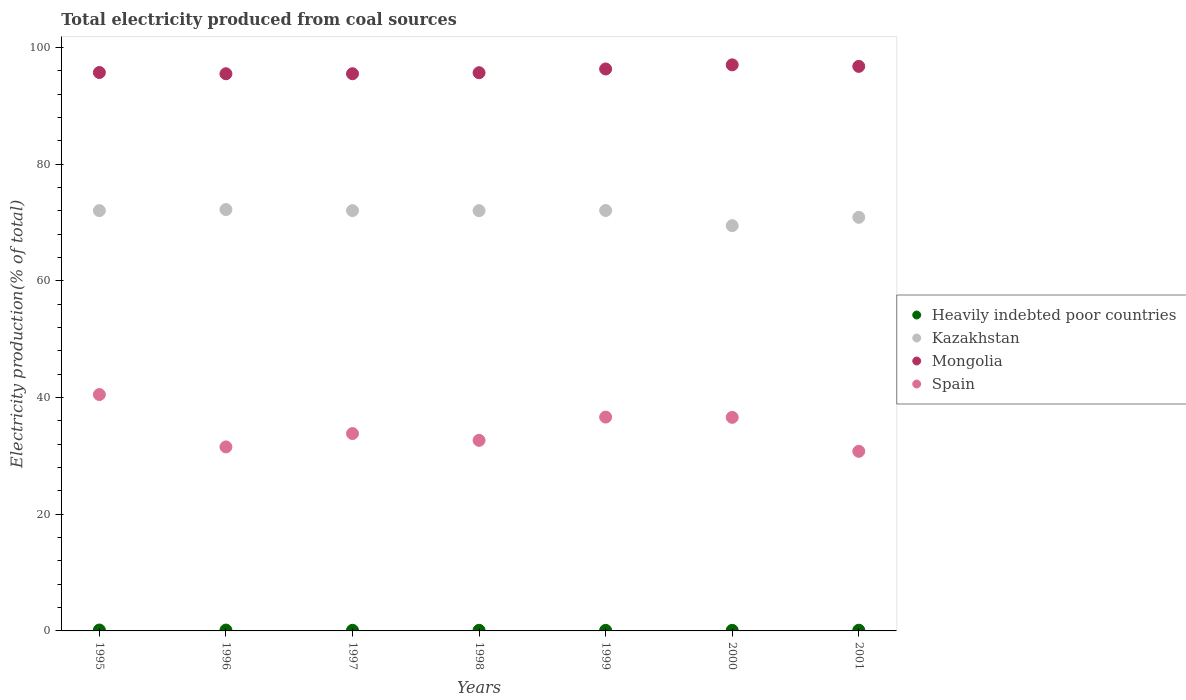How many different coloured dotlines are there?
Offer a terse response. 4. What is the total electricity produced in Spain in 1997?
Your response must be concise. 33.82. Across all years, what is the maximum total electricity produced in Kazakhstan?
Your answer should be very brief. 72.21. Across all years, what is the minimum total electricity produced in Spain?
Give a very brief answer. 30.78. In which year was the total electricity produced in Heavily indebted poor countries maximum?
Your response must be concise. 1995. What is the total total electricity produced in Spain in the graph?
Your answer should be very brief. 242.55. What is the difference between the total electricity produced in Heavily indebted poor countries in 1996 and that in 2001?
Your response must be concise. 0.02. What is the difference between the total electricity produced in Spain in 1998 and the total electricity produced in Heavily indebted poor countries in 1996?
Give a very brief answer. 32.52. What is the average total electricity produced in Kazakhstan per year?
Your answer should be very brief. 71.52. In the year 1999, what is the difference between the total electricity produced in Heavily indebted poor countries and total electricity produced in Spain?
Your response must be concise. -36.55. In how many years, is the total electricity produced in Heavily indebted poor countries greater than 92 %?
Offer a very short reply. 0. What is the ratio of the total electricity produced in Mongolia in 1995 to that in 2001?
Ensure brevity in your answer.  0.99. What is the difference between the highest and the second highest total electricity produced in Heavily indebted poor countries?
Ensure brevity in your answer.  0.01. What is the difference between the highest and the lowest total electricity produced in Mongolia?
Provide a short and direct response. 1.53. Is the sum of the total electricity produced in Kazakhstan in 1995 and 2001 greater than the maximum total electricity produced in Heavily indebted poor countries across all years?
Ensure brevity in your answer.  Yes. Is the total electricity produced in Heavily indebted poor countries strictly less than the total electricity produced in Spain over the years?
Provide a succinct answer. Yes. How many years are there in the graph?
Your response must be concise. 7. What is the difference between two consecutive major ticks on the Y-axis?
Ensure brevity in your answer.  20. Are the values on the major ticks of Y-axis written in scientific E-notation?
Your response must be concise. No. Does the graph contain grids?
Offer a very short reply. No. How many legend labels are there?
Offer a very short reply. 4. What is the title of the graph?
Offer a very short reply. Total electricity produced from coal sources. Does "Korea (Republic)" appear as one of the legend labels in the graph?
Your answer should be very brief. No. What is the label or title of the Y-axis?
Ensure brevity in your answer.  Electricity production(% of total). What is the Electricity production(% of total) in Heavily indebted poor countries in 1995?
Offer a terse response. 0.15. What is the Electricity production(% of total) of Kazakhstan in 1995?
Provide a short and direct response. 72.03. What is the Electricity production(% of total) in Mongolia in 1995?
Provide a short and direct response. 95.7. What is the Electricity production(% of total) in Spain in 1995?
Provide a short and direct response. 40.51. What is the Electricity production(% of total) in Heavily indebted poor countries in 1996?
Make the answer very short. 0.14. What is the Electricity production(% of total) of Kazakhstan in 1996?
Your answer should be very brief. 72.21. What is the Electricity production(% of total) of Mongolia in 1996?
Your response must be concise. 95.49. What is the Electricity production(% of total) of Spain in 1996?
Ensure brevity in your answer.  31.53. What is the Electricity production(% of total) of Heavily indebted poor countries in 1997?
Make the answer very short. 0.11. What is the Electricity production(% of total) of Kazakhstan in 1997?
Offer a very short reply. 72.03. What is the Electricity production(% of total) in Mongolia in 1997?
Ensure brevity in your answer.  95.49. What is the Electricity production(% of total) in Spain in 1997?
Give a very brief answer. 33.82. What is the Electricity production(% of total) in Heavily indebted poor countries in 1998?
Your response must be concise. 0.1. What is the Electricity production(% of total) in Kazakhstan in 1998?
Offer a terse response. 72.03. What is the Electricity production(% of total) in Mongolia in 1998?
Ensure brevity in your answer.  95.66. What is the Electricity production(% of total) of Spain in 1998?
Ensure brevity in your answer.  32.66. What is the Electricity production(% of total) in Heavily indebted poor countries in 1999?
Ensure brevity in your answer.  0.1. What is the Electricity production(% of total) in Kazakhstan in 1999?
Provide a succinct answer. 72.05. What is the Electricity production(% of total) of Mongolia in 1999?
Provide a short and direct response. 96.31. What is the Electricity production(% of total) in Spain in 1999?
Give a very brief answer. 36.65. What is the Electricity production(% of total) in Heavily indebted poor countries in 2000?
Provide a short and direct response. 0.1. What is the Electricity production(% of total) of Kazakhstan in 2000?
Offer a terse response. 69.45. What is the Electricity production(% of total) in Mongolia in 2000?
Your answer should be compact. 97.01. What is the Electricity production(% of total) in Spain in 2000?
Your answer should be very brief. 36.6. What is the Electricity production(% of total) of Heavily indebted poor countries in 2001?
Ensure brevity in your answer.  0.12. What is the Electricity production(% of total) of Kazakhstan in 2001?
Give a very brief answer. 70.88. What is the Electricity production(% of total) of Mongolia in 2001?
Make the answer very short. 96.75. What is the Electricity production(% of total) in Spain in 2001?
Give a very brief answer. 30.78. Across all years, what is the maximum Electricity production(% of total) of Heavily indebted poor countries?
Offer a very short reply. 0.15. Across all years, what is the maximum Electricity production(% of total) in Kazakhstan?
Provide a succinct answer. 72.21. Across all years, what is the maximum Electricity production(% of total) in Mongolia?
Provide a succinct answer. 97.01. Across all years, what is the maximum Electricity production(% of total) in Spain?
Give a very brief answer. 40.51. Across all years, what is the minimum Electricity production(% of total) in Heavily indebted poor countries?
Your answer should be compact. 0.1. Across all years, what is the minimum Electricity production(% of total) in Kazakhstan?
Your answer should be very brief. 69.45. Across all years, what is the minimum Electricity production(% of total) in Mongolia?
Your answer should be compact. 95.49. Across all years, what is the minimum Electricity production(% of total) in Spain?
Provide a short and direct response. 30.78. What is the total Electricity production(% of total) of Heavily indebted poor countries in the graph?
Give a very brief answer. 0.82. What is the total Electricity production(% of total) of Kazakhstan in the graph?
Give a very brief answer. 500.67. What is the total Electricity production(% of total) of Mongolia in the graph?
Keep it short and to the point. 672.41. What is the total Electricity production(% of total) in Spain in the graph?
Your answer should be compact. 242.55. What is the difference between the Electricity production(% of total) in Heavily indebted poor countries in 1995 and that in 1996?
Offer a terse response. 0.01. What is the difference between the Electricity production(% of total) in Kazakhstan in 1995 and that in 1996?
Provide a succinct answer. -0.18. What is the difference between the Electricity production(% of total) in Mongolia in 1995 and that in 1996?
Give a very brief answer. 0.21. What is the difference between the Electricity production(% of total) of Spain in 1995 and that in 1996?
Your answer should be compact. 8.97. What is the difference between the Electricity production(% of total) of Heavily indebted poor countries in 1995 and that in 1997?
Give a very brief answer. 0.05. What is the difference between the Electricity production(% of total) in Kazakhstan in 1995 and that in 1997?
Give a very brief answer. 0. What is the difference between the Electricity production(% of total) of Mongolia in 1995 and that in 1997?
Keep it short and to the point. 0.21. What is the difference between the Electricity production(% of total) in Spain in 1995 and that in 1997?
Your answer should be very brief. 6.68. What is the difference between the Electricity production(% of total) of Heavily indebted poor countries in 1995 and that in 1998?
Keep it short and to the point. 0.05. What is the difference between the Electricity production(% of total) of Kazakhstan in 1995 and that in 1998?
Your answer should be compact. 0. What is the difference between the Electricity production(% of total) in Mongolia in 1995 and that in 1998?
Give a very brief answer. 0.04. What is the difference between the Electricity production(% of total) of Spain in 1995 and that in 1998?
Make the answer very short. 7.85. What is the difference between the Electricity production(% of total) in Heavily indebted poor countries in 1995 and that in 1999?
Provide a succinct answer. 0.06. What is the difference between the Electricity production(% of total) in Kazakhstan in 1995 and that in 1999?
Your answer should be compact. -0.02. What is the difference between the Electricity production(% of total) of Mongolia in 1995 and that in 1999?
Keep it short and to the point. -0.61. What is the difference between the Electricity production(% of total) of Spain in 1995 and that in 1999?
Make the answer very short. 3.86. What is the difference between the Electricity production(% of total) of Heavily indebted poor countries in 1995 and that in 2000?
Your answer should be compact. 0.05. What is the difference between the Electricity production(% of total) in Kazakhstan in 1995 and that in 2000?
Provide a succinct answer. 2.58. What is the difference between the Electricity production(% of total) in Mongolia in 1995 and that in 2000?
Provide a succinct answer. -1.31. What is the difference between the Electricity production(% of total) in Spain in 1995 and that in 2000?
Offer a very short reply. 3.91. What is the difference between the Electricity production(% of total) in Heavily indebted poor countries in 1995 and that in 2001?
Keep it short and to the point. 0.03. What is the difference between the Electricity production(% of total) in Kazakhstan in 1995 and that in 2001?
Give a very brief answer. 1.15. What is the difference between the Electricity production(% of total) in Mongolia in 1995 and that in 2001?
Keep it short and to the point. -1.05. What is the difference between the Electricity production(% of total) in Spain in 1995 and that in 2001?
Your answer should be compact. 9.73. What is the difference between the Electricity production(% of total) in Heavily indebted poor countries in 1996 and that in 1997?
Keep it short and to the point. 0.04. What is the difference between the Electricity production(% of total) in Kazakhstan in 1996 and that in 1997?
Keep it short and to the point. 0.18. What is the difference between the Electricity production(% of total) of Mongolia in 1996 and that in 1997?
Ensure brevity in your answer.  -0.01. What is the difference between the Electricity production(% of total) in Spain in 1996 and that in 1997?
Your answer should be very brief. -2.29. What is the difference between the Electricity production(% of total) of Heavily indebted poor countries in 1996 and that in 1998?
Give a very brief answer. 0.04. What is the difference between the Electricity production(% of total) in Kazakhstan in 1996 and that in 1998?
Provide a succinct answer. 0.18. What is the difference between the Electricity production(% of total) of Mongolia in 1996 and that in 1998?
Offer a terse response. -0.18. What is the difference between the Electricity production(% of total) in Spain in 1996 and that in 1998?
Provide a succinct answer. -1.13. What is the difference between the Electricity production(% of total) in Heavily indebted poor countries in 1996 and that in 1999?
Offer a terse response. 0.05. What is the difference between the Electricity production(% of total) in Kazakhstan in 1996 and that in 1999?
Give a very brief answer. 0.16. What is the difference between the Electricity production(% of total) of Mongolia in 1996 and that in 1999?
Keep it short and to the point. -0.82. What is the difference between the Electricity production(% of total) of Spain in 1996 and that in 1999?
Provide a short and direct response. -5.11. What is the difference between the Electricity production(% of total) of Heavily indebted poor countries in 1996 and that in 2000?
Provide a succinct answer. 0.04. What is the difference between the Electricity production(% of total) in Kazakhstan in 1996 and that in 2000?
Make the answer very short. 2.76. What is the difference between the Electricity production(% of total) of Mongolia in 1996 and that in 2000?
Make the answer very short. -1.53. What is the difference between the Electricity production(% of total) of Spain in 1996 and that in 2000?
Provide a succinct answer. -5.07. What is the difference between the Electricity production(% of total) in Heavily indebted poor countries in 1996 and that in 2001?
Offer a very short reply. 0.02. What is the difference between the Electricity production(% of total) in Kazakhstan in 1996 and that in 2001?
Offer a very short reply. 1.33. What is the difference between the Electricity production(% of total) in Mongolia in 1996 and that in 2001?
Keep it short and to the point. -1.27. What is the difference between the Electricity production(% of total) in Spain in 1996 and that in 2001?
Your response must be concise. 0.76. What is the difference between the Electricity production(% of total) of Heavily indebted poor countries in 1997 and that in 1998?
Offer a terse response. 0. What is the difference between the Electricity production(% of total) in Kazakhstan in 1997 and that in 1998?
Your answer should be very brief. 0. What is the difference between the Electricity production(% of total) of Mongolia in 1997 and that in 1998?
Your answer should be compact. -0.17. What is the difference between the Electricity production(% of total) of Spain in 1997 and that in 1998?
Ensure brevity in your answer.  1.16. What is the difference between the Electricity production(% of total) in Heavily indebted poor countries in 1997 and that in 1999?
Give a very brief answer. 0.01. What is the difference between the Electricity production(% of total) in Kazakhstan in 1997 and that in 1999?
Offer a very short reply. -0.02. What is the difference between the Electricity production(% of total) of Mongolia in 1997 and that in 1999?
Make the answer very short. -0.81. What is the difference between the Electricity production(% of total) in Spain in 1997 and that in 1999?
Offer a very short reply. -2.83. What is the difference between the Electricity production(% of total) in Heavily indebted poor countries in 1997 and that in 2000?
Offer a very short reply. 0. What is the difference between the Electricity production(% of total) in Kazakhstan in 1997 and that in 2000?
Your response must be concise. 2.58. What is the difference between the Electricity production(% of total) of Mongolia in 1997 and that in 2000?
Your response must be concise. -1.52. What is the difference between the Electricity production(% of total) of Spain in 1997 and that in 2000?
Ensure brevity in your answer.  -2.78. What is the difference between the Electricity production(% of total) of Heavily indebted poor countries in 1997 and that in 2001?
Your answer should be very brief. -0.02. What is the difference between the Electricity production(% of total) of Kazakhstan in 1997 and that in 2001?
Your answer should be very brief. 1.15. What is the difference between the Electricity production(% of total) of Mongolia in 1997 and that in 2001?
Keep it short and to the point. -1.26. What is the difference between the Electricity production(% of total) of Spain in 1997 and that in 2001?
Give a very brief answer. 3.05. What is the difference between the Electricity production(% of total) of Heavily indebted poor countries in 1998 and that in 1999?
Ensure brevity in your answer.  0.01. What is the difference between the Electricity production(% of total) of Kazakhstan in 1998 and that in 1999?
Offer a terse response. -0.02. What is the difference between the Electricity production(% of total) in Mongolia in 1998 and that in 1999?
Give a very brief answer. -0.64. What is the difference between the Electricity production(% of total) in Spain in 1998 and that in 1999?
Offer a very short reply. -3.99. What is the difference between the Electricity production(% of total) in Heavily indebted poor countries in 1998 and that in 2000?
Provide a short and direct response. 0. What is the difference between the Electricity production(% of total) of Kazakhstan in 1998 and that in 2000?
Make the answer very short. 2.57. What is the difference between the Electricity production(% of total) of Mongolia in 1998 and that in 2000?
Offer a very short reply. -1.35. What is the difference between the Electricity production(% of total) in Spain in 1998 and that in 2000?
Provide a short and direct response. -3.94. What is the difference between the Electricity production(% of total) of Heavily indebted poor countries in 1998 and that in 2001?
Keep it short and to the point. -0.02. What is the difference between the Electricity production(% of total) in Kazakhstan in 1998 and that in 2001?
Make the answer very short. 1.14. What is the difference between the Electricity production(% of total) in Mongolia in 1998 and that in 2001?
Provide a short and direct response. -1.09. What is the difference between the Electricity production(% of total) in Spain in 1998 and that in 2001?
Offer a very short reply. 1.88. What is the difference between the Electricity production(% of total) in Heavily indebted poor countries in 1999 and that in 2000?
Provide a short and direct response. -0.01. What is the difference between the Electricity production(% of total) of Kazakhstan in 1999 and that in 2000?
Give a very brief answer. 2.6. What is the difference between the Electricity production(% of total) in Mongolia in 1999 and that in 2000?
Offer a terse response. -0.71. What is the difference between the Electricity production(% of total) of Spain in 1999 and that in 2000?
Your answer should be compact. 0.05. What is the difference between the Electricity production(% of total) in Heavily indebted poor countries in 1999 and that in 2001?
Make the answer very short. -0.03. What is the difference between the Electricity production(% of total) of Kazakhstan in 1999 and that in 2001?
Your response must be concise. 1.17. What is the difference between the Electricity production(% of total) of Mongolia in 1999 and that in 2001?
Offer a terse response. -0.45. What is the difference between the Electricity production(% of total) of Spain in 1999 and that in 2001?
Your answer should be very brief. 5.87. What is the difference between the Electricity production(% of total) in Heavily indebted poor countries in 2000 and that in 2001?
Your response must be concise. -0.02. What is the difference between the Electricity production(% of total) in Kazakhstan in 2000 and that in 2001?
Offer a very short reply. -1.43. What is the difference between the Electricity production(% of total) in Mongolia in 2000 and that in 2001?
Provide a short and direct response. 0.26. What is the difference between the Electricity production(% of total) in Spain in 2000 and that in 2001?
Ensure brevity in your answer.  5.82. What is the difference between the Electricity production(% of total) in Heavily indebted poor countries in 1995 and the Electricity production(% of total) in Kazakhstan in 1996?
Your answer should be compact. -72.06. What is the difference between the Electricity production(% of total) of Heavily indebted poor countries in 1995 and the Electricity production(% of total) of Mongolia in 1996?
Your answer should be very brief. -95.33. What is the difference between the Electricity production(% of total) of Heavily indebted poor countries in 1995 and the Electricity production(% of total) of Spain in 1996?
Ensure brevity in your answer.  -31.38. What is the difference between the Electricity production(% of total) in Kazakhstan in 1995 and the Electricity production(% of total) in Mongolia in 1996?
Ensure brevity in your answer.  -23.46. What is the difference between the Electricity production(% of total) of Kazakhstan in 1995 and the Electricity production(% of total) of Spain in 1996?
Make the answer very short. 40.5. What is the difference between the Electricity production(% of total) of Mongolia in 1995 and the Electricity production(% of total) of Spain in 1996?
Offer a terse response. 64.17. What is the difference between the Electricity production(% of total) of Heavily indebted poor countries in 1995 and the Electricity production(% of total) of Kazakhstan in 1997?
Make the answer very short. -71.88. What is the difference between the Electricity production(% of total) in Heavily indebted poor countries in 1995 and the Electricity production(% of total) in Mongolia in 1997?
Offer a terse response. -95.34. What is the difference between the Electricity production(% of total) in Heavily indebted poor countries in 1995 and the Electricity production(% of total) in Spain in 1997?
Provide a short and direct response. -33.67. What is the difference between the Electricity production(% of total) of Kazakhstan in 1995 and the Electricity production(% of total) of Mongolia in 1997?
Offer a very short reply. -23.46. What is the difference between the Electricity production(% of total) in Kazakhstan in 1995 and the Electricity production(% of total) in Spain in 1997?
Provide a succinct answer. 38.21. What is the difference between the Electricity production(% of total) of Mongolia in 1995 and the Electricity production(% of total) of Spain in 1997?
Provide a succinct answer. 61.88. What is the difference between the Electricity production(% of total) in Heavily indebted poor countries in 1995 and the Electricity production(% of total) in Kazakhstan in 1998?
Your answer should be compact. -71.87. What is the difference between the Electricity production(% of total) in Heavily indebted poor countries in 1995 and the Electricity production(% of total) in Mongolia in 1998?
Your answer should be very brief. -95.51. What is the difference between the Electricity production(% of total) of Heavily indebted poor countries in 1995 and the Electricity production(% of total) of Spain in 1998?
Your answer should be very brief. -32.51. What is the difference between the Electricity production(% of total) of Kazakhstan in 1995 and the Electricity production(% of total) of Mongolia in 1998?
Make the answer very short. -23.63. What is the difference between the Electricity production(% of total) of Kazakhstan in 1995 and the Electricity production(% of total) of Spain in 1998?
Give a very brief answer. 39.37. What is the difference between the Electricity production(% of total) in Mongolia in 1995 and the Electricity production(% of total) in Spain in 1998?
Make the answer very short. 63.04. What is the difference between the Electricity production(% of total) of Heavily indebted poor countries in 1995 and the Electricity production(% of total) of Kazakhstan in 1999?
Ensure brevity in your answer.  -71.89. What is the difference between the Electricity production(% of total) in Heavily indebted poor countries in 1995 and the Electricity production(% of total) in Mongolia in 1999?
Ensure brevity in your answer.  -96.15. What is the difference between the Electricity production(% of total) in Heavily indebted poor countries in 1995 and the Electricity production(% of total) in Spain in 1999?
Your answer should be very brief. -36.5. What is the difference between the Electricity production(% of total) in Kazakhstan in 1995 and the Electricity production(% of total) in Mongolia in 1999?
Offer a terse response. -24.28. What is the difference between the Electricity production(% of total) of Kazakhstan in 1995 and the Electricity production(% of total) of Spain in 1999?
Provide a short and direct response. 35.38. What is the difference between the Electricity production(% of total) in Mongolia in 1995 and the Electricity production(% of total) in Spain in 1999?
Keep it short and to the point. 59.05. What is the difference between the Electricity production(% of total) in Heavily indebted poor countries in 1995 and the Electricity production(% of total) in Kazakhstan in 2000?
Make the answer very short. -69.3. What is the difference between the Electricity production(% of total) in Heavily indebted poor countries in 1995 and the Electricity production(% of total) in Mongolia in 2000?
Ensure brevity in your answer.  -96.86. What is the difference between the Electricity production(% of total) in Heavily indebted poor countries in 1995 and the Electricity production(% of total) in Spain in 2000?
Ensure brevity in your answer.  -36.45. What is the difference between the Electricity production(% of total) of Kazakhstan in 1995 and the Electricity production(% of total) of Mongolia in 2000?
Give a very brief answer. -24.98. What is the difference between the Electricity production(% of total) of Kazakhstan in 1995 and the Electricity production(% of total) of Spain in 2000?
Your response must be concise. 35.43. What is the difference between the Electricity production(% of total) in Mongolia in 1995 and the Electricity production(% of total) in Spain in 2000?
Keep it short and to the point. 59.1. What is the difference between the Electricity production(% of total) of Heavily indebted poor countries in 1995 and the Electricity production(% of total) of Kazakhstan in 2001?
Keep it short and to the point. -70.73. What is the difference between the Electricity production(% of total) in Heavily indebted poor countries in 1995 and the Electricity production(% of total) in Mongolia in 2001?
Give a very brief answer. -96.6. What is the difference between the Electricity production(% of total) in Heavily indebted poor countries in 1995 and the Electricity production(% of total) in Spain in 2001?
Keep it short and to the point. -30.63. What is the difference between the Electricity production(% of total) in Kazakhstan in 1995 and the Electricity production(% of total) in Mongolia in 2001?
Provide a short and direct response. -24.72. What is the difference between the Electricity production(% of total) in Kazakhstan in 1995 and the Electricity production(% of total) in Spain in 2001?
Your answer should be compact. 41.25. What is the difference between the Electricity production(% of total) in Mongolia in 1995 and the Electricity production(% of total) in Spain in 2001?
Make the answer very short. 64.92. What is the difference between the Electricity production(% of total) in Heavily indebted poor countries in 1996 and the Electricity production(% of total) in Kazakhstan in 1997?
Your response must be concise. -71.89. What is the difference between the Electricity production(% of total) of Heavily indebted poor countries in 1996 and the Electricity production(% of total) of Mongolia in 1997?
Offer a terse response. -95.35. What is the difference between the Electricity production(% of total) of Heavily indebted poor countries in 1996 and the Electricity production(% of total) of Spain in 1997?
Offer a terse response. -33.68. What is the difference between the Electricity production(% of total) in Kazakhstan in 1996 and the Electricity production(% of total) in Mongolia in 1997?
Your answer should be very brief. -23.28. What is the difference between the Electricity production(% of total) of Kazakhstan in 1996 and the Electricity production(% of total) of Spain in 1997?
Your response must be concise. 38.39. What is the difference between the Electricity production(% of total) in Mongolia in 1996 and the Electricity production(% of total) in Spain in 1997?
Make the answer very short. 61.66. What is the difference between the Electricity production(% of total) in Heavily indebted poor countries in 1996 and the Electricity production(% of total) in Kazakhstan in 1998?
Keep it short and to the point. -71.88. What is the difference between the Electricity production(% of total) of Heavily indebted poor countries in 1996 and the Electricity production(% of total) of Mongolia in 1998?
Offer a terse response. -95.52. What is the difference between the Electricity production(% of total) in Heavily indebted poor countries in 1996 and the Electricity production(% of total) in Spain in 1998?
Your answer should be very brief. -32.52. What is the difference between the Electricity production(% of total) of Kazakhstan in 1996 and the Electricity production(% of total) of Mongolia in 1998?
Make the answer very short. -23.45. What is the difference between the Electricity production(% of total) in Kazakhstan in 1996 and the Electricity production(% of total) in Spain in 1998?
Offer a very short reply. 39.55. What is the difference between the Electricity production(% of total) of Mongolia in 1996 and the Electricity production(% of total) of Spain in 1998?
Keep it short and to the point. 62.82. What is the difference between the Electricity production(% of total) of Heavily indebted poor countries in 1996 and the Electricity production(% of total) of Kazakhstan in 1999?
Your response must be concise. -71.9. What is the difference between the Electricity production(% of total) of Heavily indebted poor countries in 1996 and the Electricity production(% of total) of Mongolia in 1999?
Offer a terse response. -96.16. What is the difference between the Electricity production(% of total) of Heavily indebted poor countries in 1996 and the Electricity production(% of total) of Spain in 1999?
Provide a succinct answer. -36.51. What is the difference between the Electricity production(% of total) in Kazakhstan in 1996 and the Electricity production(% of total) in Mongolia in 1999?
Your answer should be compact. -24.1. What is the difference between the Electricity production(% of total) in Kazakhstan in 1996 and the Electricity production(% of total) in Spain in 1999?
Offer a terse response. 35.56. What is the difference between the Electricity production(% of total) in Mongolia in 1996 and the Electricity production(% of total) in Spain in 1999?
Your response must be concise. 58.84. What is the difference between the Electricity production(% of total) in Heavily indebted poor countries in 1996 and the Electricity production(% of total) in Kazakhstan in 2000?
Ensure brevity in your answer.  -69.31. What is the difference between the Electricity production(% of total) in Heavily indebted poor countries in 1996 and the Electricity production(% of total) in Mongolia in 2000?
Provide a succinct answer. -96.87. What is the difference between the Electricity production(% of total) in Heavily indebted poor countries in 1996 and the Electricity production(% of total) in Spain in 2000?
Your response must be concise. -36.46. What is the difference between the Electricity production(% of total) in Kazakhstan in 1996 and the Electricity production(% of total) in Mongolia in 2000?
Provide a short and direct response. -24.8. What is the difference between the Electricity production(% of total) of Kazakhstan in 1996 and the Electricity production(% of total) of Spain in 2000?
Ensure brevity in your answer.  35.61. What is the difference between the Electricity production(% of total) in Mongolia in 1996 and the Electricity production(% of total) in Spain in 2000?
Your answer should be very brief. 58.89. What is the difference between the Electricity production(% of total) in Heavily indebted poor countries in 1996 and the Electricity production(% of total) in Kazakhstan in 2001?
Provide a succinct answer. -70.74. What is the difference between the Electricity production(% of total) in Heavily indebted poor countries in 1996 and the Electricity production(% of total) in Mongolia in 2001?
Your answer should be compact. -96.61. What is the difference between the Electricity production(% of total) of Heavily indebted poor countries in 1996 and the Electricity production(% of total) of Spain in 2001?
Give a very brief answer. -30.64. What is the difference between the Electricity production(% of total) in Kazakhstan in 1996 and the Electricity production(% of total) in Mongolia in 2001?
Provide a succinct answer. -24.54. What is the difference between the Electricity production(% of total) of Kazakhstan in 1996 and the Electricity production(% of total) of Spain in 2001?
Offer a very short reply. 41.43. What is the difference between the Electricity production(% of total) of Mongolia in 1996 and the Electricity production(% of total) of Spain in 2001?
Give a very brief answer. 64.71. What is the difference between the Electricity production(% of total) of Heavily indebted poor countries in 1997 and the Electricity production(% of total) of Kazakhstan in 1998?
Your answer should be very brief. -71.92. What is the difference between the Electricity production(% of total) of Heavily indebted poor countries in 1997 and the Electricity production(% of total) of Mongolia in 1998?
Keep it short and to the point. -95.56. What is the difference between the Electricity production(% of total) in Heavily indebted poor countries in 1997 and the Electricity production(% of total) in Spain in 1998?
Ensure brevity in your answer.  -32.56. What is the difference between the Electricity production(% of total) of Kazakhstan in 1997 and the Electricity production(% of total) of Mongolia in 1998?
Make the answer very short. -23.63. What is the difference between the Electricity production(% of total) of Kazakhstan in 1997 and the Electricity production(% of total) of Spain in 1998?
Make the answer very short. 39.37. What is the difference between the Electricity production(% of total) in Mongolia in 1997 and the Electricity production(% of total) in Spain in 1998?
Provide a short and direct response. 62.83. What is the difference between the Electricity production(% of total) of Heavily indebted poor countries in 1997 and the Electricity production(% of total) of Kazakhstan in 1999?
Provide a succinct answer. -71.94. What is the difference between the Electricity production(% of total) in Heavily indebted poor countries in 1997 and the Electricity production(% of total) in Mongolia in 1999?
Provide a short and direct response. -96.2. What is the difference between the Electricity production(% of total) in Heavily indebted poor countries in 1997 and the Electricity production(% of total) in Spain in 1999?
Keep it short and to the point. -36.54. What is the difference between the Electricity production(% of total) of Kazakhstan in 1997 and the Electricity production(% of total) of Mongolia in 1999?
Offer a very short reply. -24.28. What is the difference between the Electricity production(% of total) in Kazakhstan in 1997 and the Electricity production(% of total) in Spain in 1999?
Your answer should be compact. 35.38. What is the difference between the Electricity production(% of total) of Mongolia in 1997 and the Electricity production(% of total) of Spain in 1999?
Give a very brief answer. 58.84. What is the difference between the Electricity production(% of total) of Heavily indebted poor countries in 1997 and the Electricity production(% of total) of Kazakhstan in 2000?
Provide a succinct answer. -69.35. What is the difference between the Electricity production(% of total) in Heavily indebted poor countries in 1997 and the Electricity production(% of total) in Mongolia in 2000?
Provide a succinct answer. -96.91. What is the difference between the Electricity production(% of total) of Heavily indebted poor countries in 1997 and the Electricity production(% of total) of Spain in 2000?
Your answer should be very brief. -36.49. What is the difference between the Electricity production(% of total) of Kazakhstan in 1997 and the Electricity production(% of total) of Mongolia in 2000?
Offer a terse response. -24.98. What is the difference between the Electricity production(% of total) of Kazakhstan in 1997 and the Electricity production(% of total) of Spain in 2000?
Provide a short and direct response. 35.43. What is the difference between the Electricity production(% of total) in Mongolia in 1997 and the Electricity production(% of total) in Spain in 2000?
Provide a short and direct response. 58.89. What is the difference between the Electricity production(% of total) of Heavily indebted poor countries in 1997 and the Electricity production(% of total) of Kazakhstan in 2001?
Your response must be concise. -70.78. What is the difference between the Electricity production(% of total) of Heavily indebted poor countries in 1997 and the Electricity production(% of total) of Mongolia in 2001?
Keep it short and to the point. -96.65. What is the difference between the Electricity production(% of total) of Heavily indebted poor countries in 1997 and the Electricity production(% of total) of Spain in 2001?
Offer a very short reply. -30.67. What is the difference between the Electricity production(% of total) in Kazakhstan in 1997 and the Electricity production(% of total) in Mongolia in 2001?
Give a very brief answer. -24.72. What is the difference between the Electricity production(% of total) of Kazakhstan in 1997 and the Electricity production(% of total) of Spain in 2001?
Ensure brevity in your answer.  41.25. What is the difference between the Electricity production(% of total) in Mongolia in 1997 and the Electricity production(% of total) in Spain in 2001?
Your response must be concise. 64.71. What is the difference between the Electricity production(% of total) in Heavily indebted poor countries in 1998 and the Electricity production(% of total) in Kazakhstan in 1999?
Keep it short and to the point. -71.94. What is the difference between the Electricity production(% of total) in Heavily indebted poor countries in 1998 and the Electricity production(% of total) in Mongolia in 1999?
Provide a succinct answer. -96.2. What is the difference between the Electricity production(% of total) in Heavily indebted poor countries in 1998 and the Electricity production(% of total) in Spain in 1999?
Provide a succinct answer. -36.54. What is the difference between the Electricity production(% of total) in Kazakhstan in 1998 and the Electricity production(% of total) in Mongolia in 1999?
Provide a succinct answer. -24.28. What is the difference between the Electricity production(% of total) in Kazakhstan in 1998 and the Electricity production(% of total) in Spain in 1999?
Offer a very short reply. 35.38. What is the difference between the Electricity production(% of total) of Mongolia in 1998 and the Electricity production(% of total) of Spain in 1999?
Your answer should be very brief. 59.02. What is the difference between the Electricity production(% of total) of Heavily indebted poor countries in 1998 and the Electricity production(% of total) of Kazakhstan in 2000?
Make the answer very short. -69.35. What is the difference between the Electricity production(% of total) of Heavily indebted poor countries in 1998 and the Electricity production(% of total) of Mongolia in 2000?
Your response must be concise. -96.91. What is the difference between the Electricity production(% of total) of Heavily indebted poor countries in 1998 and the Electricity production(% of total) of Spain in 2000?
Ensure brevity in your answer.  -36.5. What is the difference between the Electricity production(% of total) in Kazakhstan in 1998 and the Electricity production(% of total) in Mongolia in 2000?
Your response must be concise. -24.99. What is the difference between the Electricity production(% of total) of Kazakhstan in 1998 and the Electricity production(% of total) of Spain in 2000?
Offer a very short reply. 35.43. What is the difference between the Electricity production(% of total) in Mongolia in 1998 and the Electricity production(% of total) in Spain in 2000?
Your response must be concise. 59.06. What is the difference between the Electricity production(% of total) in Heavily indebted poor countries in 1998 and the Electricity production(% of total) in Kazakhstan in 2001?
Give a very brief answer. -70.78. What is the difference between the Electricity production(% of total) in Heavily indebted poor countries in 1998 and the Electricity production(% of total) in Mongolia in 2001?
Provide a short and direct response. -96.65. What is the difference between the Electricity production(% of total) of Heavily indebted poor countries in 1998 and the Electricity production(% of total) of Spain in 2001?
Ensure brevity in your answer.  -30.67. What is the difference between the Electricity production(% of total) in Kazakhstan in 1998 and the Electricity production(% of total) in Mongolia in 2001?
Give a very brief answer. -24.73. What is the difference between the Electricity production(% of total) of Kazakhstan in 1998 and the Electricity production(% of total) of Spain in 2001?
Your response must be concise. 41.25. What is the difference between the Electricity production(% of total) in Mongolia in 1998 and the Electricity production(% of total) in Spain in 2001?
Your answer should be very brief. 64.89. What is the difference between the Electricity production(% of total) in Heavily indebted poor countries in 1999 and the Electricity production(% of total) in Kazakhstan in 2000?
Give a very brief answer. -69.36. What is the difference between the Electricity production(% of total) in Heavily indebted poor countries in 1999 and the Electricity production(% of total) in Mongolia in 2000?
Your answer should be compact. -96.92. What is the difference between the Electricity production(% of total) in Heavily indebted poor countries in 1999 and the Electricity production(% of total) in Spain in 2000?
Offer a terse response. -36.5. What is the difference between the Electricity production(% of total) in Kazakhstan in 1999 and the Electricity production(% of total) in Mongolia in 2000?
Offer a very short reply. -24.97. What is the difference between the Electricity production(% of total) of Kazakhstan in 1999 and the Electricity production(% of total) of Spain in 2000?
Make the answer very short. 35.45. What is the difference between the Electricity production(% of total) in Mongolia in 1999 and the Electricity production(% of total) in Spain in 2000?
Ensure brevity in your answer.  59.7. What is the difference between the Electricity production(% of total) in Heavily indebted poor countries in 1999 and the Electricity production(% of total) in Kazakhstan in 2001?
Your response must be concise. -70.79. What is the difference between the Electricity production(% of total) of Heavily indebted poor countries in 1999 and the Electricity production(% of total) of Mongolia in 2001?
Offer a very short reply. -96.66. What is the difference between the Electricity production(% of total) in Heavily indebted poor countries in 1999 and the Electricity production(% of total) in Spain in 2001?
Offer a very short reply. -30.68. What is the difference between the Electricity production(% of total) in Kazakhstan in 1999 and the Electricity production(% of total) in Mongolia in 2001?
Ensure brevity in your answer.  -24.7. What is the difference between the Electricity production(% of total) in Kazakhstan in 1999 and the Electricity production(% of total) in Spain in 2001?
Offer a very short reply. 41.27. What is the difference between the Electricity production(% of total) of Mongolia in 1999 and the Electricity production(% of total) of Spain in 2001?
Provide a succinct answer. 65.53. What is the difference between the Electricity production(% of total) of Heavily indebted poor countries in 2000 and the Electricity production(% of total) of Kazakhstan in 2001?
Ensure brevity in your answer.  -70.78. What is the difference between the Electricity production(% of total) in Heavily indebted poor countries in 2000 and the Electricity production(% of total) in Mongolia in 2001?
Offer a terse response. -96.65. What is the difference between the Electricity production(% of total) of Heavily indebted poor countries in 2000 and the Electricity production(% of total) of Spain in 2001?
Ensure brevity in your answer.  -30.68. What is the difference between the Electricity production(% of total) of Kazakhstan in 2000 and the Electricity production(% of total) of Mongolia in 2001?
Your response must be concise. -27.3. What is the difference between the Electricity production(% of total) in Kazakhstan in 2000 and the Electricity production(% of total) in Spain in 2001?
Your response must be concise. 38.67. What is the difference between the Electricity production(% of total) in Mongolia in 2000 and the Electricity production(% of total) in Spain in 2001?
Give a very brief answer. 66.23. What is the average Electricity production(% of total) of Heavily indebted poor countries per year?
Offer a terse response. 0.12. What is the average Electricity production(% of total) of Kazakhstan per year?
Provide a succinct answer. 71.52. What is the average Electricity production(% of total) in Mongolia per year?
Provide a succinct answer. 96.06. What is the average Electricity production(% of total) in Spain per year?
Provide a short and direct response. 34.65. In the year 1995, what is the difference between the Electricity production(% of total) in Heavily indebted poor countries and Electricity production(% of total) in Kazakhstan?
Provide a succinct answer. -71.88. In the year 1995, what is the difference between the Electricity production(% of total) of Heavily indebted poor countries and Electricity production(% of total) of Mongolia?
Your response must be concise. -95.55. In the year 1995, what is the difference between the Electricity production(% of total) of Heavily indebted poor countries and Electricity production(% of total) of Spain?
Ensure brevity in your answer.  -40.35. In the year 1995, what is the difference between the Electricity production(% of total) in Kazakhstan and Electricity production(% of total) in Mongolia?
Provide a short and direct response. -23.67. In the year 1995, what is the difference between the Electricity production(% of total) of Kazakhstan and Electricity production(% of total) of Spain?
Provide a short and direct response. 31.52. In the year 1995, what is the difference between the Electricity production(% of total) of Mongolia and Electricity production(% of total) of Spain?
Ensure brevity in your answer.  55.19. In the year 1996, what is the difference between the Electricity production(% of total) in Heavily indebted poor countries and Electricity production(% of total) in Kazakhstan?
Your response must be concise. -72.07. In the year 1996, what is the difference between the Electricity production(% of total) in Heavily indebted poor countries and Electricity production(% of total) in Mongolia?
Your answer should be compact. -95.34. In the year 1996, what is the difference between the Electricity production(% of total) of Heavily indebted poor countries and Electricity production(% of total) of Spain?
Ensure brevity in your answer.  -31.39. In the year 1996, what is the difference between the Electricity production(% of total) of Kazakhstan and Electricity production(% of total) of Mongolia?
Your answer should be very brief. -23.28. In the year 1996, what is the difference between the Electricity production(% of total) of Kazakhstan and Electricity production(% of total) of Spain?
Your answer should be very brief. 40.67. In the year 1996, what is the difference between the Electricity production(% of total) of Mongolia and Electricity production(% of total) of Spain?
Offer a terse response. 63.95. In the year 1997, what is the difference between the Electricity production(% of total) in Heavily indebted poor countries and Electricity production(% of total) in Kazakhstan?
Give a very brief answer. -71.92. In the year 1997, what is the difference between the Electricity production(% of total) of Heavily indebted poor countries and Electricity production(% of total) of Mongolia?
Make the answer very short. -95.39. In the year 1997, what is the difference between the Electricity production(% of total) of Heavily indebted poor countries and Electricity production(% of total) of Spain?
Offer a terse response. -33.72. In the year 1997, what is the difference between the Electricity production(% of total) of Kazakhstan and Electricity production(% of total) of Mongolia?
Make the answer very short. -23.46. In the year 1997, what is the difference between the Electricity production(% of total) of Kazakhstan and Electricity production(% of total) of Spain?
Give a very brief answer. 38.21. In the year 1997, what is the difference between the Electricity production(% of total) in Mongolia and Electricity production(% of total) in Spain?
Give a very brief answer. 61.67. In the year 1998, what is the difference between the Electricity production(% of total) of Heavily indebted poor countries and Electricity production(% of total) of Kazakhstan?
Ensure brevity in your answer.  -71.92. In the year 1998, what is the difference between the Electricity production(% of total) in Heavily indebted poor countries and Electricity production(% of total) in Mongolia?
Your answer should be very brief. -95.56. In the year 1998, what is the difference between the Electricity production(% of total) of Heavily indebted poor countries and Electricity production(% of total) of Spain?
Keep it short and to the point. -32.56. In the year 1998, what is the difference between the Electricity production(% of total) of Kazakhstan and Electricity production(% of total) of Mongolia?
Offer a terse response. -23.64. In the year 1998, what is the difference between the Electricity production(% of total) in Kazakhstan and Electricity production(% of total) in Spain?
Your response must be concise. 39.36. In the year 1998, what is the difference between the Electricity production(% of total) in Mongolia and Electricity production(% of total) in Spain?
Ensure brevity in your answer.  63. In the year 1999, what is the difference between the Electricity production(% of total) in Heavily indebted poor countries and Electricity production(% of total) in Kazakhstan?
Your response must be concise. -71.95. In the year 1999, what is the difference between the Electricity production(% of total) in Heavily indebted poor countries and Electricity production(% of total) in Mongolia?
Make the answer very short. -96.21. In the year 1999, what is the difference between the Electricity production(% of total) in Heavily indebted poor countries and Electricity production(% of total) in Spain?
Provide a short and direct response. -36.55. In the year 1999, what is the difference between the Electricity production(% of total) of Kazakhstan and Electricity production(% of total) of Mongolia?
Your response must be concise. -24.26. In the year 1999, what is the difference between the Electricity production(% of total) in Kazakhstan and Electricity production(% of total) in Spain?
Your answer should be very brief. 35.4. In the year 1999, what is the difference between the Electricity production(% of total) in Mongolia and Electricity production(% of total) in Spain?
Your answer should be very brief. 59.66. In the year 2000, what is the difference between the Electricity production(% of total) of Heavily indebted poor countries and Electricity production(% of total) of Kazakhstan?
Make the answer very short. -69.35. In the year 2000, what is the difference between the Electricity production(% of total) of Heavily indebted poor countries and Electricity production(% of total) of Mongolia?
Your response must be concise. -96.91. In the year 2000, what is the difference between the Electricity production(% of total) in Heavily indebted poor countries and Electricity production(% of total) in Spain?
Give a very brief answer. -36.5. In the year 2000, what is the difference between the Electricity production(% of total) of Kazakhstan and Electricity production(% of total) of Mongolia?
Offer a terse response. -27.56. In the year 2000, what is the difference between the Electricity production(% of total) in Kazakhstan and Electricity production(% of total) in Spain?
Your answer should be compact. 32.85. In the year 2000, what is the difference between the Electricity production(% of total) of Mongolia and Electricity production(% of total) of Spain?
Keep it short and to the point. 60.41. In the year 2001, what is the difference between the Electricity production(% of total) in Heavily indebted poor countries and Electricity production(% of total) in Kazakhstan?
Your answer should be very brief. -70.76. In the year 2001, what is the difference between the Electricity production(% of total) in Heavily indebted poor countries and Electricity production(% of total) in Mongolia?
Make the answer very short. -96.63. In the year 2001, what is the difference between the Electricity production(% of total) of Heavily indebted poor countries and Electricity production(% of total) of Spain?
Your response must be concise. -30.66. In the year 2001, what is the difference between the Electricity production(% of total) of Kazakhstan and Electricity production(% of total) of Mongolia?
Provide a succinct answer. -25.87. In the year 2001, what is the difference between the Electricity production(% of total) of Kazakhstan and Electricity production(% of total) of Spain?
Offer a terse response. 40.1. In the year 2001, what is the difference between the Electricity production(% of total) of Mongolia and Electricity production(% of total) of Spain?
Offer a very short reply. 65.97. What is the ratio of the Electricity production(% of total) of Heavily indebted poor countries in 1995 to that in 1996?
Your response must be concise. 1.07. What is the ratio of the Electricity production(% of total) in Spain in 1995 to that in 1996?
Ensure brevity in your answer.  1.28. What is the ratio of the Electricity production(% of total) of Heavily indebted poor countries in 1995 to that in 1997?
Your answer should be compact. 1.45. What is the ratio of the Electricity production(% of total) of Kazakhstan in 1995 to that in 1997?
Offer a very short reply. 1. What is the ratio of the Electricity production(% of total) in Spain in 1995 to that in 1997?
Ensure brevity in your answer.  1.2. What is the ratio of the Electricity production(% of total) in Heavily indebted poor countries in 1995 to that in 1998?
Provide a short and direct response. 1.47. What is the ratio of the Electricity production(% of total) of Mongolia in 1995 to that in 1998?
Provide a short and direct response. 1. What is the ratio of the Electricity production(% of total) of Spain in 1995 to that in 1998?
Provide a succinct answer. 1.24. What is the ratio of the Electricity production(% of total) in Heavily indebted poor countries in 1995 to that in 1999?
Give a very brief answer. 1.6. What is the ratio of the Electricity production(% of total) in Kazakhstan in 1995 to that in 1999?
Provide a short and direct response. 1. What is the ratio of the Electricity production(% of total) in Spain in 1995 to that in 1999?
Ensure brevity in your answer.  1.11. What is the ratio of the Electricity production(% of total) of Heavily indebted poor countries in 1995 to that in 2000?
Offer a terse response. 1.5. What is the ratio of the Electricity production(% of total) of Kazakhstan in 1995 to that in 2000?
Your answer should be very brief. 1.04. What is the ratio of the Electricity production(% of total) of Mongolia in 1995 to that in 2000?
Offer a very short reply. 0.99. What is the ratio of the Electricity production(% of total) of Spain in 1995 to that in 2000?
Your answer should be compact. 1.11. What is the ratio of the Electricity production(% of total) in Heavily indebted poor countries in 1995 to that in 2001?
Offer a very short reply. 1.26. What is the ratio of the Electricity production(% of total) in Kazakhstan in 1995 to that in 2001?
Give a very brief answer. 1.02. What is the ratio of the Electricity production(% of total) of Mongolia in 1995 to that in 2001?
Give a very brief answer. 0.99. What is the ratio of the Electricity production(% of total) in Spain in 1995 to that in 2001?
Give a very brief answer. 1.32. What is the ratio of the Electricity production(% of total) of Heavily indebted poor countries in 1996 to that in 1997?
Keep it short and to the point. 1.35. What is the ratio of the Electricity production(% of total) in Spain in 1996 to that in 1997?
Give a very brief answer. 0.93. What is the ratio of the Electricity production(% of total) in Heavily indebted poor countries in 1996 to that in 1998?
Your answer should be very brief. 1.37. What is the ratio of the Electricity production(% of total) in Spain in 1996 to that in 1998?
Provide a short and direct response. 0.97. What is the ratio of the Electricity production(% of total) of Heavily indebted poor countries in 1996 to that in 1999?
Offer a very short reply. 1.49. What is the ratio of the Electricity production(% of total) of Kazakhstan in 1996 to that in 1999?
Offer a very short reply. 1. What is the ratio of the Electricity production(% of total) of Mongolia in 1996 to that in 1999?
Your answer should be compact. 0.99. What is the ratio of the Electricity production(% of total) of Spain in 1996 to that in 1999?
Offer a very short reply. 0.86. What is the ratio of the Electricity production(% of total) in Heavily indebted poor countries in 1996 to that in 2000?
Provide a succinct answer. 1.4. What is the ratio of the Electricity production(% of total) in Kazakhstan in 1996 to that in 2000?
Make the answer very short. 1.04. What is the ratio of the Electricity production(% of total) in Mongolia in 1996 to that in 2000?
Your response must be concise. 0.98. What is the ratio of the Electricity production(% of total) of Spain in 1996 to that in 2000?
Provide a short and direct response. 0.86. What is the ratio of the Electricity production(% of total) of Heavily indebted poor countries in 1996 to that in 2001?
Keep it short and to the point. 1.17. What is the ratio of the Electricity production(% of total) of Kazakhstan in 1996 to that in 2001?
Offer a very short reply. 1.02. What is the ratio of the Electricity production(% of total) of Mongolia in 1996 to that in 2001?
Make the answer very short. 0.99. What is the ratio of the Electricity production(% of total) of Spain in 1996 to that in 2001?
Provide a succinct answer. 1.02. What is the ratio of the Electricity production(% of total) of Heavily indebted poor countries in 1997 to that in 1998?
Your answer should be compact. 1.02. What is the ratio of the Electricity production(% of total) in Mongolia in 1997 to that in 1998?
Offer a terse response. 1. What is the ratio of the Electricity production(% of total) of Spain in 1997 to that in 1998?
Provide a succinct answer. 1.04. What is the ratio of the Electricity production(% of total) of Heavily indebted poor countries in 1997 to that in 1999?
Provide a short and direct response. 1.11. What is the ratio of the Electricity production(% of total) in Spain in 1997 to that in 1999?
Make the answer very short. 0.92. What is the ratio of the Electricity production(% of total) in Heavily indebted poor countries in 1997 to that in 2000?
Keep it short and to the point. 1.04. What is the ratio of the Electricity production(% of total) of Kazakhstan in 1997 to that in 2000?
Provide a short and direct response. 1.04. What is the ratio of the Electricity production(% of total) in Mongolia in 1997 to that in 2000?
Your response must be concise. 0.98. What is the ratio of the Electricity production(% of total) of Spain in 1997 to that in 2000?
Your response must be concise. 0.92. What is the ratio of the Electricity production(% of total) of Heavily indebted poor countries in 1997 to that in 2001?
Ensure brevity in your answer.  0.87. What is the ratio of the Electricity production(% of total) in Kazakhstan in 1997 to that in 2001?
Offer a very short reply. 1.02. What is the ratio of the Electricity production(% of total) of Spain in 1997 to that in 2001?
Your answer should be compact. 1.1. What is the ratio of the Electricity production(% of total) in Heavily indebted poor countries in 1998 to that in 1999?
Keep it short and to the point. 1.09. What is the ratio of the Electricity production(% of total) in Spain in 1998 to that in 1999?
Offer a very short reply. 0.89. What is the ratio of the Electricity production(% of total) of Heavily indebted poor countries in 1998 to that in 2000?
Make the answer very short. 1.02. What is the ratio of the Electricity production(% of total) in Kazakhstan in 1998 to that in 2000?
Ensure brevity in your answer.  1.04. What is the ratio of the Electricity production(% of total) in Mongolia in 1998 to that in 2000?
Offer a terse response. 0.99. What is the ratio of the Electricity production(% of total) of Spain in 1998 to that in 2000?
Offer a terse response. 0.89. What is the ratio of the Electricity production(% of total) of Heavily indebted poor countries in 1998 to that in 2001?
Your response must be concise. 0.85. What is the ratio of the Electricity production(% of total) of Kazakhstan in 1998 to that in 2001?
Provide a succinct answer. 1.02. What is the ratio of the Electricity production(% of total) in Mongolia in 1998 to that in 2001?
Your response must be concise. 0.99. What is the ratio of the Electricity production(% of total) of Spain in 1998 to that in 2001?
Ensure brevity in your answer.  1.06. What is the ratio of the Electricity production(% of total) of Heavily indebted poor countries in 1999 to that in 2000?
Your response must be concise. 0.94. What is the ratio of the Electricity production(% of total) of Kazakhstan in 1999 to that in 2000?
Give a very brief answer. 1.04. What is the ratio of the Electricity production(% of total) of Spain in 1999 to that in 2000?
Give a very brief answer. 1. What is the ratio of the Electricity production(% of total) in Heavily indebted poor countries in 1999 to that in 2001?
Provide a short and direct response. 0.79. What is the ratio of the Electricity production(% of total) of Kazakhstan in 1999 to that in 2001?
Keep it short and to the point. 1.02. What is the ratio of the Electricity production(% of total) of Mongolia in 1999 to that in 2001?
Provide a succinct answer. 1. What is the ratio of the Electricity production(% of total) of Spain in 1999 to that in 2001?
Make the answer very short. 1.19. What is the ratio of the Electricity production(% of total) of Heavily indebted poor countries in 2000 to that in 2001?
Give a very brief answer. 0.84. What is the ratio of the Electricity production(% of total) in Kazakhstan in 2000 to that in 2001?
Your answer should be compact. 0.98. What is the ratio of the Electricity production(% of total) of Mongolia in 2000 to that in 2001?
Offer a terse response. 1. What is the ratio of the Electricity production(% of total) of Spain in 2000 to that in 2001?
Make the answer very short. 1.19. What is the difference between the highest and the second highest Electricity production(% of total) in Heavily indebted poor countries?
Provide a succinct answer. 0.01. What is the difference between the highest and the second highest Electricity production(% of total) in Kazakhstan?
Provide a short and direct response. 0.16. What is the difference between the highest and the second highest Electricity production(% of total) of Mongolia?
Your answer should be compact. 0.26. What is the difference between the highest and the second highest Electricity production(% of total) of Spain?
Give a very brief answer. 3.86. What is the difference between the highest and the lowest Electricity production(% of total) in Heavily indebted poor countries?
Ensure brevity in your answer.  0.06. What is the difference between the highest and the lowest Electricity production(% of total) of Kazakhstan?
Your answer should be compact. 2.76. What is the difference between the highest and the lowest Electricity production(% of total) in Mongolia?
Ensure brevity in your answer.  1.53. What is the difference between the highest and the lowest Electricity production(% of total) of Spain?
Your response must be concise. 9.73. 